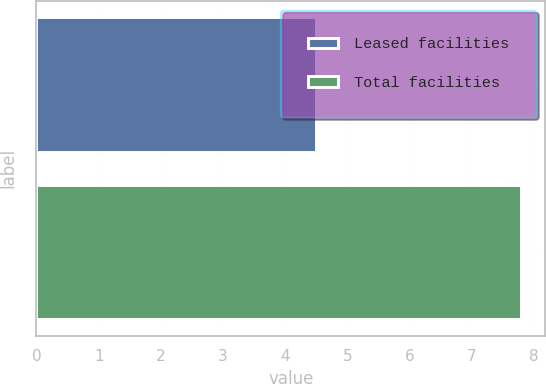Convert chart. <chart><loc_0><loc_0><loc_500><loc_500><bar_chart><fcel>Leased facilities<fcel>Total facilities<nl><fcel>4.5<fcel>7.8<nl></chart> 